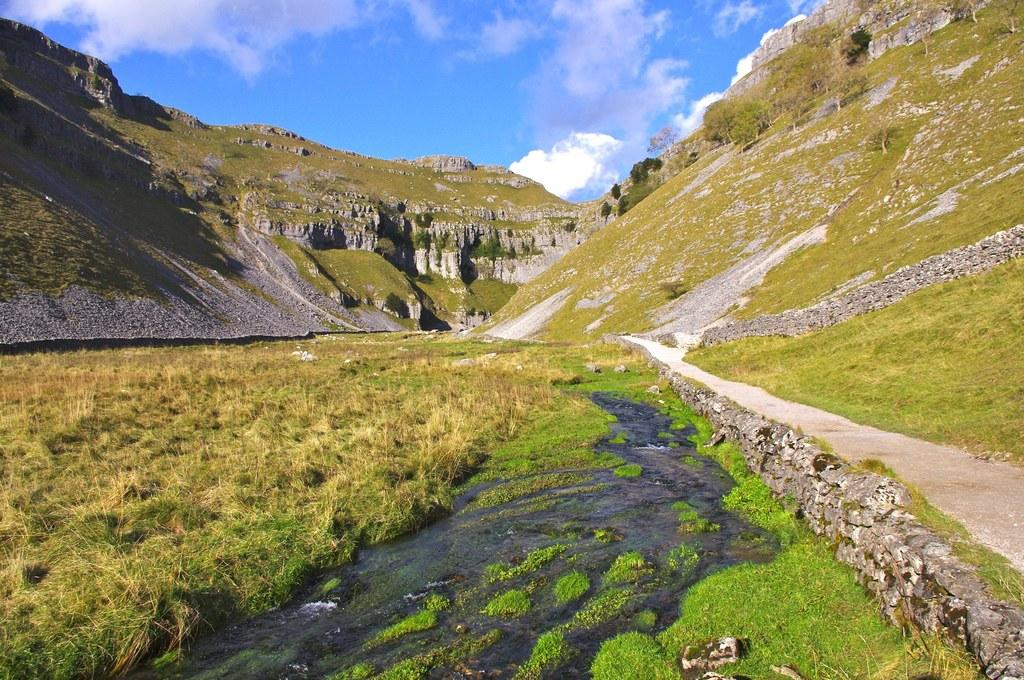What type of vegetation can be seen in the image? There is grass in the image. What else can be seen besides grass? There is water, hills, and the sky visible in the image. What is the ground like in the image? The ground is visible in the image. What can be seen in the sky? Clouds are present in the sky. How much money is being exchanged between the donkey and the beetle in the image? There is no donkey or beetle present in the image, and therefore no such exchange can be observed. 